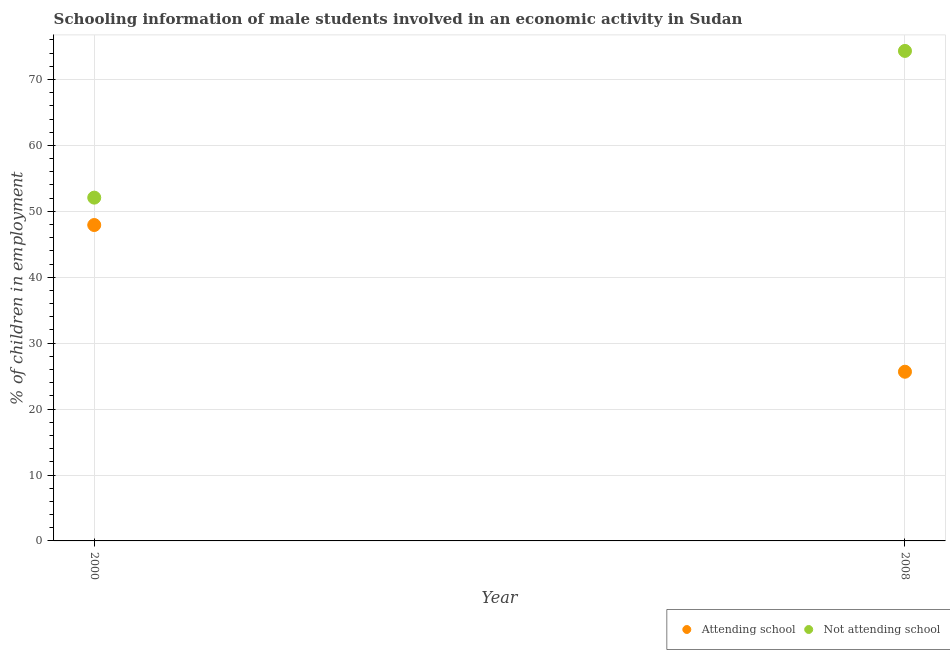What is the percentage of employed males who are not attending school in 2008?
Provide a short and direct response. 74.33. Across all years, what is the maximum percentage of employed males who are not attending school?
Ensure brevity in your answer.  74.33. Across all years, what is the minimum percentage of employed males who are not attending school?
Make the answer very short. 52.08. In which year was the percentage of employed males who are not attending school maximum?
Provide a short and direct response. 2008. In which year was the percentage of employed males who are not attending school minimum?
Provide a short and direct response. 2000. What is the total percentage of employed males who are not attending school in the graph?
Keep it short and to the point. 126.41. What is the difference between the percentage of employed males who are not attending school in 2000 and that in 2008?
Your answer should be compact. -22.26. What is the difference between the percentage of employed males who are attending school in 2000 and the percentage of employed males who are not attending school in 2008?
Your answer should be very brief. -26.41. What is the average percentage of employed males who are not attending school per year?
Offer a very short reply. 63.21. In the year 2000, what is the difference between the percentage of employed males who are attending school and percentage of employed males who are not attending school?
Your response must be concise. -4.16. In how many years, is the percentage of employed males who are not attending school greater than 8 %?
Your answer should be compact. 2. What is the ratio of the percentage of employed males who are attending school in 2000 to that in 2008?
Provide a short and direct response. 1.87. Is the percentage of employed males who are not attending school in 2000 less than that in 2008?
Your response must be concise. Yes. In how many years, is the percentage of employed males who are not attending school greater than the average percentage of employed males who are not attending school taken over all years?
Provide a succinct answer. 1. Does the percentage of employed males who are not attending school monotonically increase over the years?
Keep it short and to the point. Yes. How many years are there in the graph?
Keep it short and to the point. 2. What is the difference between two consecutive major ticks on the Y-axis?
Offer a very short reply. 10. How many legend labels are there?
Provide a succinct answer. 2. What is the title of the graph?
Offer a very short reply. Schooling information of male students involved in an economic activity in Sudan. What is the label or title of the Y-axis?
Ensure brevity in your answer.  % of children in employment. What is the % of children in employment in Attending school in 2000?
Keep it short and to the point. 47.92. What is the % of children in employment of Not attending school in 2000?
Offer a terse response. 52.08. What is the % of children in employment in Attending school in 2008?
Your answer should be compact. 25.67. What is the % of children in employment in Not attending school in 2008?
Give a very brief answer. 74.33. Across all years, what is the maximum % of children in employment in Attending school?
Your response must be concise. 47.92. Across all years, what is the maximum % of children in employment of Not attending school?
Keep it short and to the point. 74.33. Across all years, what is the minimum % of children in employment of Attending school?
Provide a short and direct response. 25.67. Across all years, what is the minimum % of children in employment in Not attending school?
Your answer should be compact. 52.08. What is the total % of children in employment in Attending school in the graph?
Offer a very short reply. 73.59. What is the total % of children in employment in Not attending school in the graph?
Keep it short and to the point. 126.41. What is the difference between the % of children in employment of Attending school in 2000 and that in 2008?
Your response must be concise. 22.26. What is the difference between the % of children in employment of Not attending school in 2000 and that in 2008?
Offer a very short reply. -22.26. What is the difference between the % of children in employment in Attending school in 2000 and the % of children in employment in Not attending school in 2008?
Make the answer very short. -26.41. What is the average % of children in employment in Attending school per year?
Ensure brevity in your answer.  36.79. What is the average % of children in employment of Not attending school per year?
Provide a short and direct response. 63.21. In the year 2000, what is the difference between the % of children in employment in Attending school and % of children in employment in Not attending school?
Your answer should be very brief. -4.16. In the year 2008, what is the difference between the % of children in employment of Attending school and % of children in employment of Not attending school?
Ensure brevity in your answer.  -48.67. What is the ratio of the % of children in employment of Attending school in 2000 to that in 2008?
Ensure brevity in your answer.  1.87. What is the ratio of the % of children in employment of Not attending school in 2000 to that in 2008?
Provide a succinct answer. 0.7. What is the difference between the highest and the second highest % of children in employment in Attending school?
Provide a succinct answer. 22.26. What is the difference between the highest and the second highest % of children in employment in Not attending school?
Provide a short and direct response. 22.26. What is the difference between the highest and the lowest % of children in employment in Attending school?
Provide a short and direct response. 22.26. What is the difference between the highest and the lowest % of children in employment in Not attending school?
Keep it short and to the point. 22.26. 